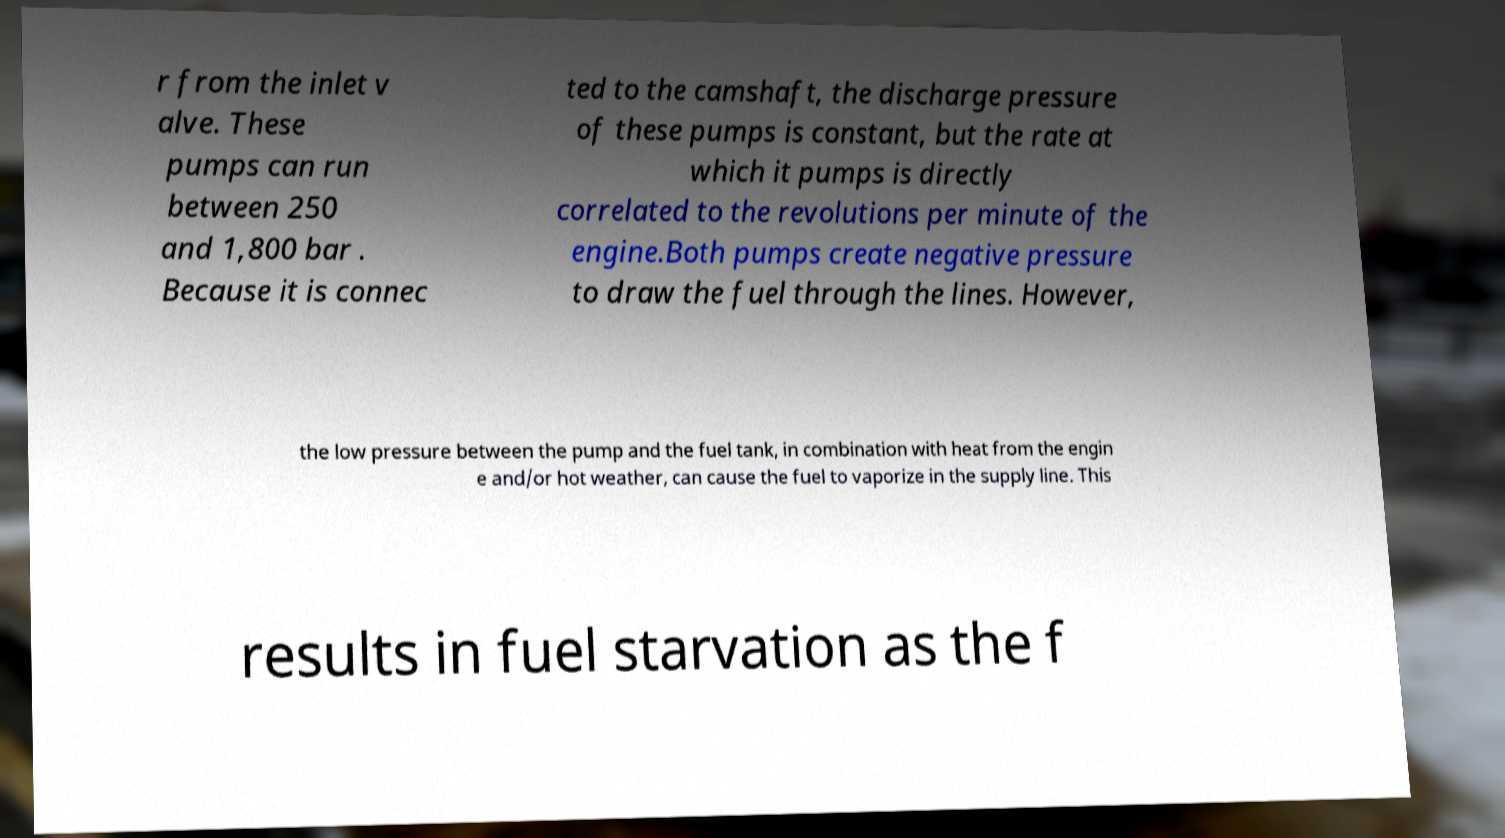I need the written content from this picture converted into text. Can you do that? r from the inlet v alve. These pumps can run between 250 and 1,800 bar . Because it is connec ted to the camshaft, the discharge pressure of these pumps is constant, but the rate at which it pumps is directly correlated to the revolutions per minute of the engine.Both pumps create negative pressure to draw the fuel through the lines. However, the low pressure between the pump and the fuel tank, in combination with heat from the engin e and/or hot weather, can cause the fuel to vaporize in the supply line. This results in fuel starvation as the f 